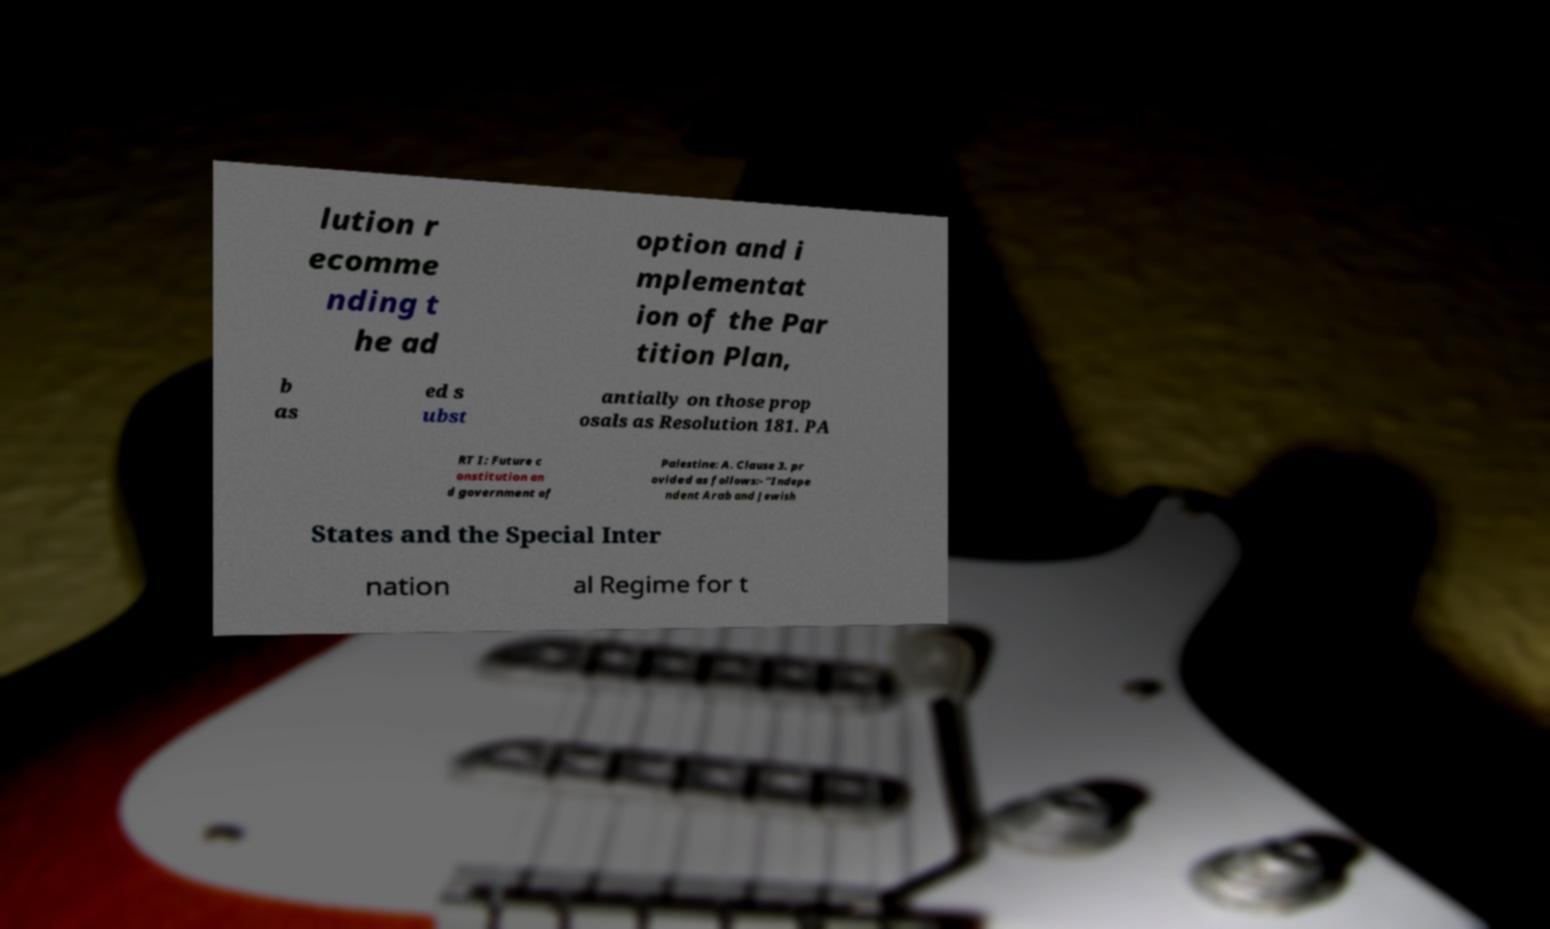Can you accurately transcribe the text from the provided image for me? lution r ecomme nding t he ad option and i mplementat ion of the Par tition Plan, b as ed s ubst antially on those prop osals as Resolution 181. PA RT I: Future c onstitution an d government of Palestine: A. Clause 3. pr ovided as follows:- "Indepe ndent Arab and Jewish States and the Special Inter nation al Regime for t 